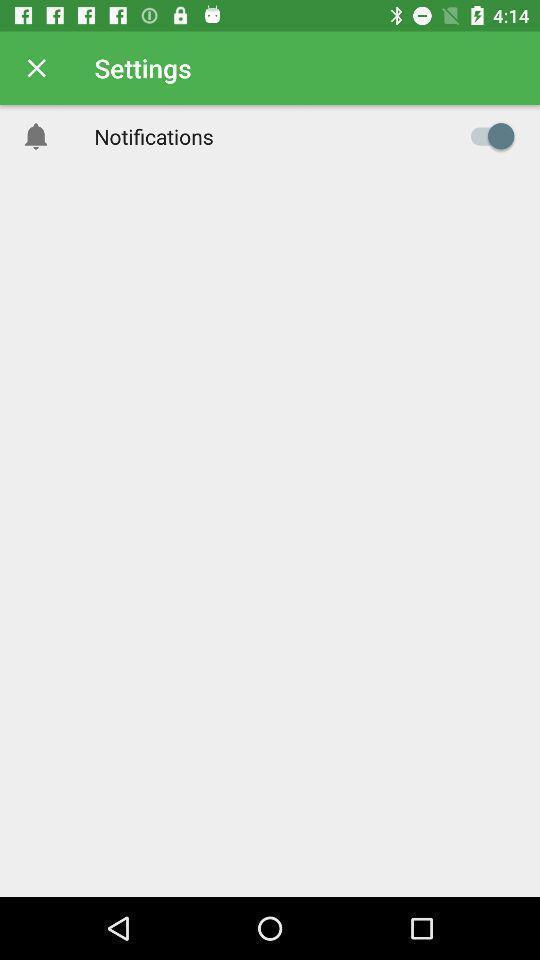Tell me about the visual elements in this screen capture. Window displaying a settings page. 